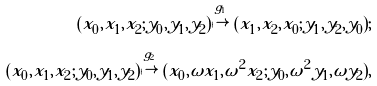Convert formula to latex. <formula><loc_0><loc_0><loc_500><loc_500>( x _ { 0 } , x _ { 1 } , x _ { 2 } ; y _ { 0 } , y _ { 1 } , y _ { 2 } ) \overset { g _ { 1 } } { \mapsto } ( x _ { 1 } , x _ { 2 } , x _ { 0 } ; y _ { 1 } , y _ { 2 } , y _ { 0 } ) ; \\ ( x _ { 0 } , x _ { 1 } , x _ { 2 } ; y _ { 0 } , y _ { 1 } , y _ { 2 } ) \overset { g _ { 2 } } { \mapsto } ( x _ { 0 } , \omega x _ { 1 } , \omega ^ { 2 } x _ { 2 } ; y _ { 0 } , \omega ^ { 2 } y _ { 1 } , \omega y _ { 2 } ) ,</formula> 